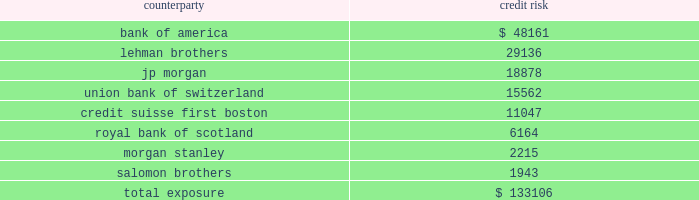Mortgage banking activities the company enters into commitments to originate loans whereby the interest rate on the loan is determined prior to funding .
These commitments are referred to as interest rate lock commitments ( 201cirlcs 201d ) .
Irlcs on loans that the company intends to sell are considered to be derivatives and are , therefore , recorded at fair value with changes in fair value recorded in earnings .
For purposes of determining fair value , the company estimates the fair value of an irlc based on the estimated fair value of the underlying mortgage loan and the probability that the mortgage loan will fund within the terms of the irlc .
The fair value excludes the market value associated with the anticipated sale of servicing rights related to each loan commitment .
The fair value of these irlcs was a $ 0.06 million and a $ 0.02 million liability at december 31 , 2007 and 2006 , respectively .
The company also designates fair value relationships of closed loans held-for-sale against a combination of mortgage forwards and short treasury positions .
Short treasury relationships are economic hedges , rather than fair value or cash flow hedges .
Short treasury positions are marked-to-market , but do not receive hedge accounting treatment under sfas no .
133 , as amended .
The mark-to-market of the mortgage forwards is included in the net change of the irlcs and the related hedging instruments .
The fair value of the mark-to-market on closed loans was a $ 1.2 thousand and $ 1.7 million asset at december 31 , 2007 and 2006 , respectively .
Irlcs , as well as closed loans held-for-sale , expose the company to interest rate risk .
The company manages this risk by selling mortgages or mortgage-backed securities on a forward basis referred to as forward sale agreements .
Changes in the fair value of these derivatives are included as gain ( loss ) on loans and securities , net in the consolidated statement of income ( loss ) .
The net change in irlcs , closed loans , mortgage forwards and the short treasury positions generated a net loss of $ 2.4 million in 2007 , a net gain of $ 1.6 million in 2006 and a net loss of $ 0.4 million in 2005 .
Credit risk credit risk is managed by limiting activity to approved counterparties and setting aggregate exposure limits for each approved counterparty .
The credit risk , or maximum exposure , which results from interest rate swaps and purchased interest rate options is represented by the fair value of contracts that have unrealized gains at the reporting date .
Conversely , we have $ 197.5 million of derivative contracts with unrealized losses at december 31 , 2007 .
The company pledged approximately $ 87.4 million of its mortgage-backed securities as collateral of derivative contracts .
While the company does not expect that any counterparty will fail to perform , the table shows the maximum exposure associated with each counterparty to interest rate swaps and purchased interest rate options at december 31 , 2007 ( dollars in thousands ) : counterparty credit .

What percentage of counterparty exposure at december 31 2007 is represented by union bank of switzerland? 
Rationale: percentage of exposure is important to monitor for counter parties as their deterioration is potentially significant .
Computations: (15562 / 133106)
Answer: 0.11691. 